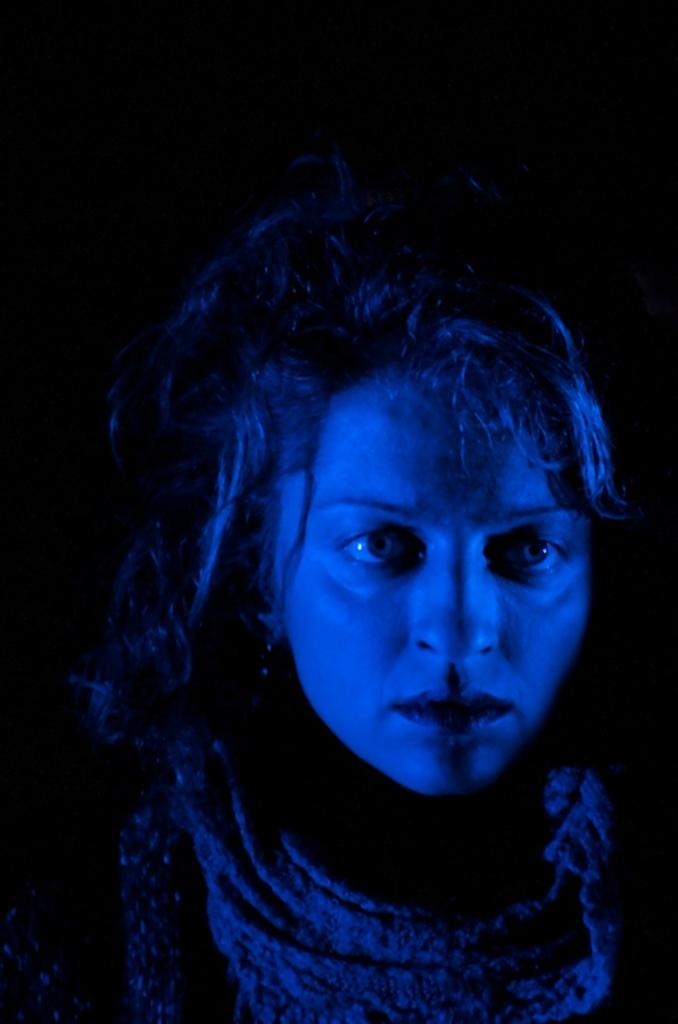What is the main subject of the image? There is a person in the image. Can you describe the background of the image? The background of the image is dark. What type of iron is being used to adjust the heat in the image? There is no iron or heat adjustment present in the image; it only features a person with a dark background. 